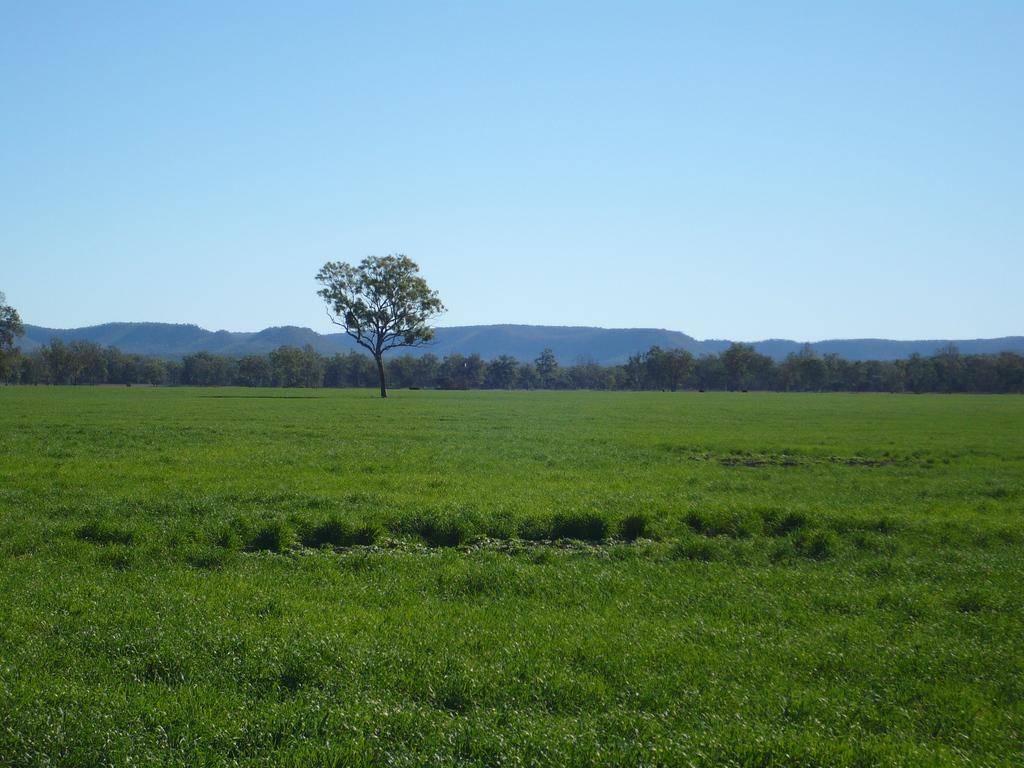How would you summarize this image in a sentence or two? In this image at the bottom there is grass and some plants, and in the background there are mountains and trees. At the top there is sky. 